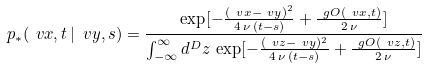<formula> <loc_0><loc_0><loc_500><loc_500>p _ { * } ( \ v x , t \, | \, \ v y , s ) = \frac { \exp [ - \frac { ( \ v x - \ v y ) ^ { 2 } } { 4 \, \nu \, ( t - s ) } + \frac { \ g O ( \ v x , t ) } { 2 \, \nu } ] } { \int _ { - \infty } ^ { \infty } d ^ { D } z \, \exp [ - \frac { ( \ v z - \ v y ) ^ { 2 } } { 4 \, \nu \, ( t - s ) } + \frac { \ g O ( \ v z , t ) } { 2 \, \nu } ] }</formula> 